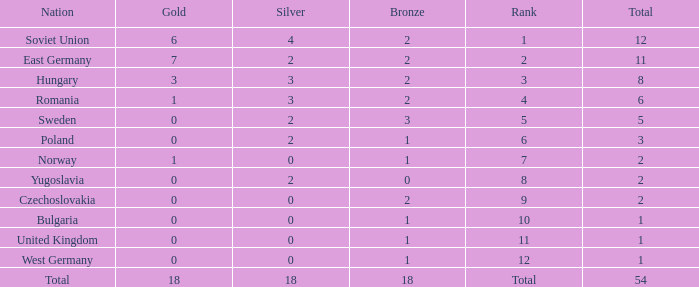What's the highest total of Romania when the bronze was less than 2? None. 